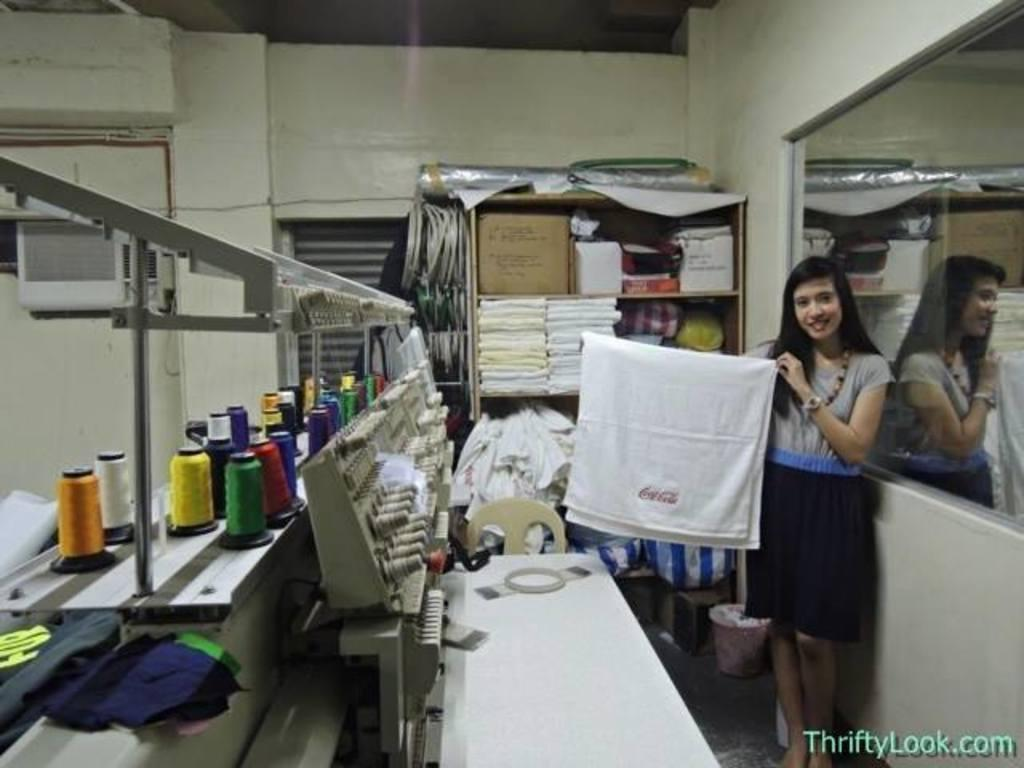Who is present in the image? There is a woman in the image. What is the woman holding in her hands? The woman is holding a cloth in her hands. What other objects can be seen in the image? There are bottles in the image. What piece of furniture is visible in the image? There is a table in the image. What can be seen in the background of the image? There is a rack and a wall in the background of the image. What type of list is the woman holding in her hands? The woman is not holding a list in her hands; she is holding a cloth. Can you see a carriage in the image? There is no carriage present in the image. 